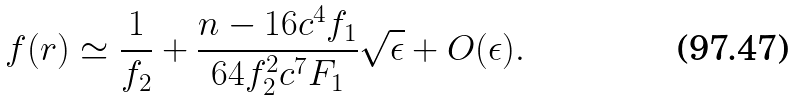Convert formula to latex. <formula><loc_0><loc_0><loc_500><loc_500>f ( r ) \simeq \frac { 1 } { f _ { 2 } } + \frac { n - 1 6 c ^ { 4 } f _ { 1 } } { 6 4 f _ { 2 } ^ { 2 } c ^ { 7 } F _ { 1 } } \sqrt { \epsilon } + O ( \epsilon ) .</formula> 